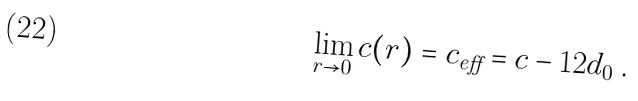<formula> <loc_0><loc_0><loc_500><loc_500>\lim _ { r \rightarrow 0 } c ( r ) = c _ { \text {eff} } = c - 1 2 d _ { 0 } \, .</formula> 